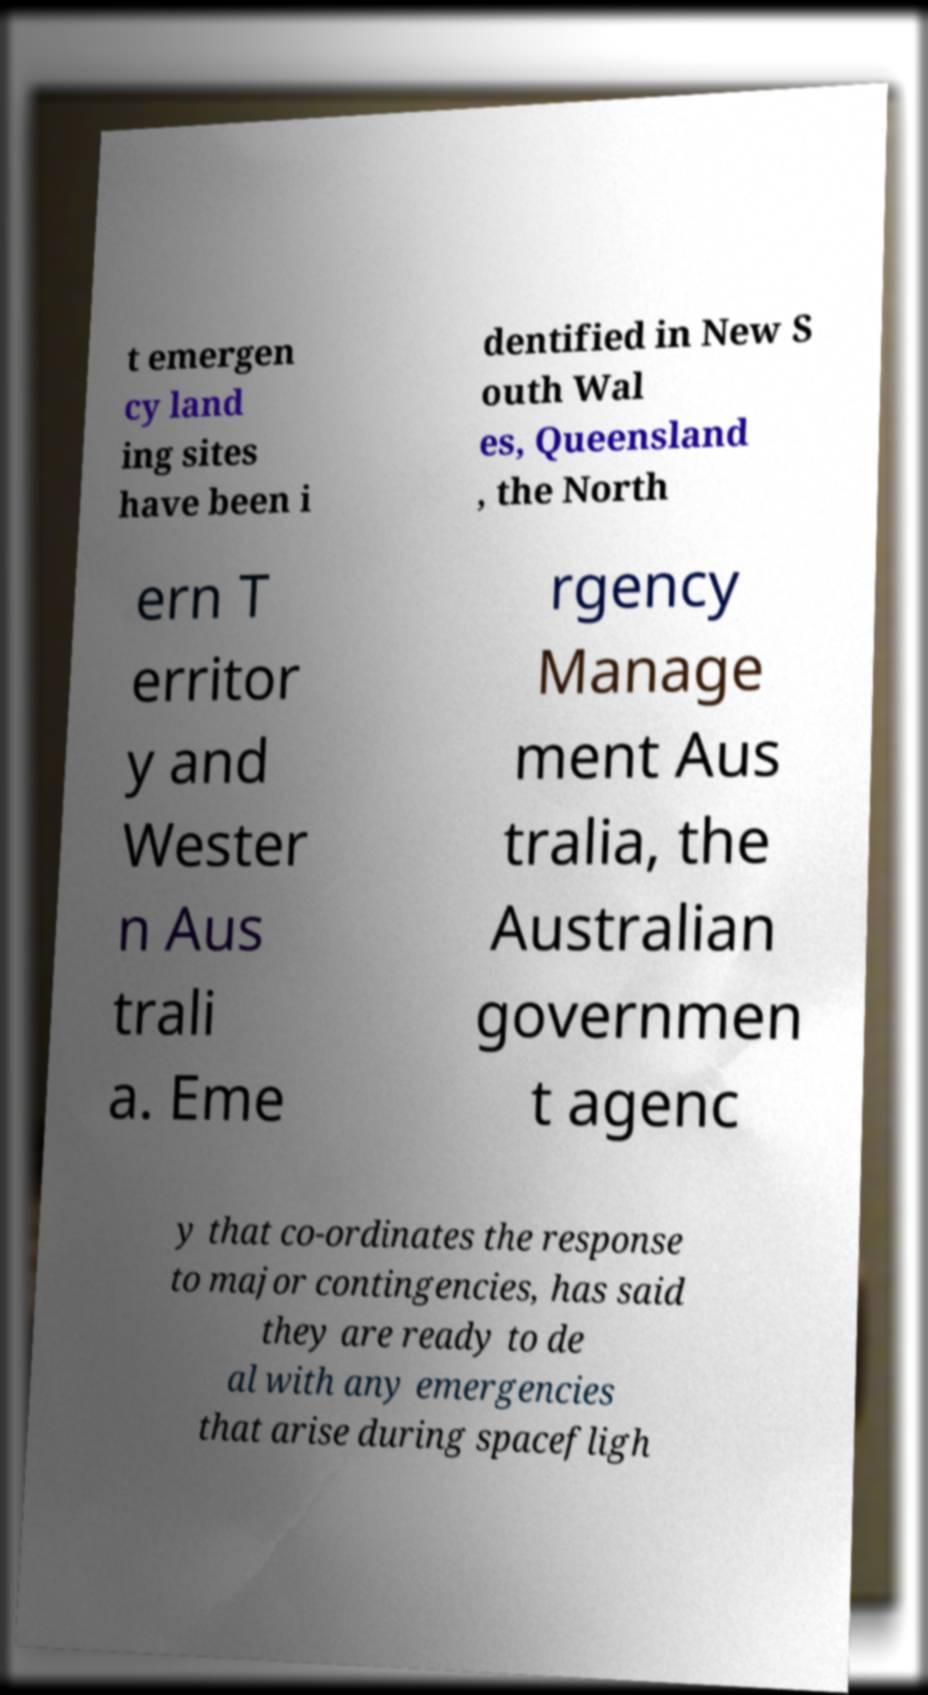Could you assist in decoding the text presented in this image and type it out clearly? t emergen cy land ing sites have been i dentified in New S outh Wal es, Queensland , the North ern T erritor y and Wester n Aus trali a. Eme rgency Manage ment Aus tralia, the Australian governmen t agenc y that co-ordinates the response to major contingencies, has said they are ready to de al with any emergencies that arise during spacefligh 